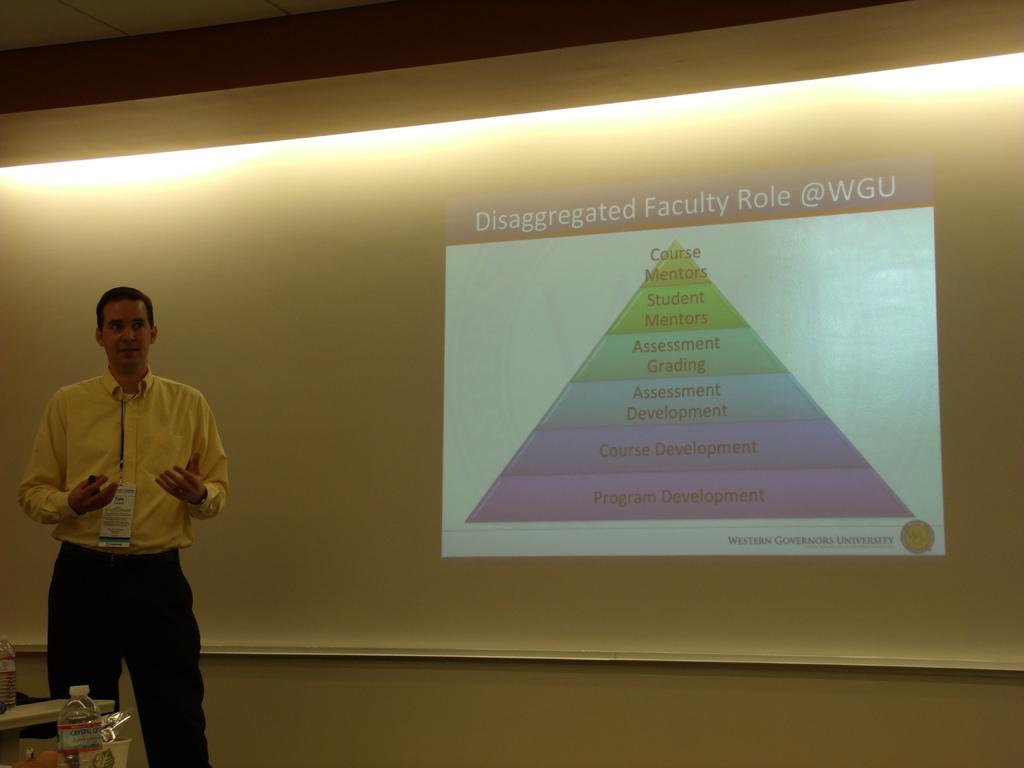What is the main subject of the image? There is a person standing in the image. What can be seen in the background of the image? There is a projection screen in the background of the image. What is being displayed on the projection screen? There is a projection visible on the screen. What type of vegetable is being used as a machine in the image? There is no vegetable or machine present in the image. What emotion does the person in the image feel about the projection on the screen? The image does not provide information about the person's emotions, so we cannot determine how they feel about the projection. 